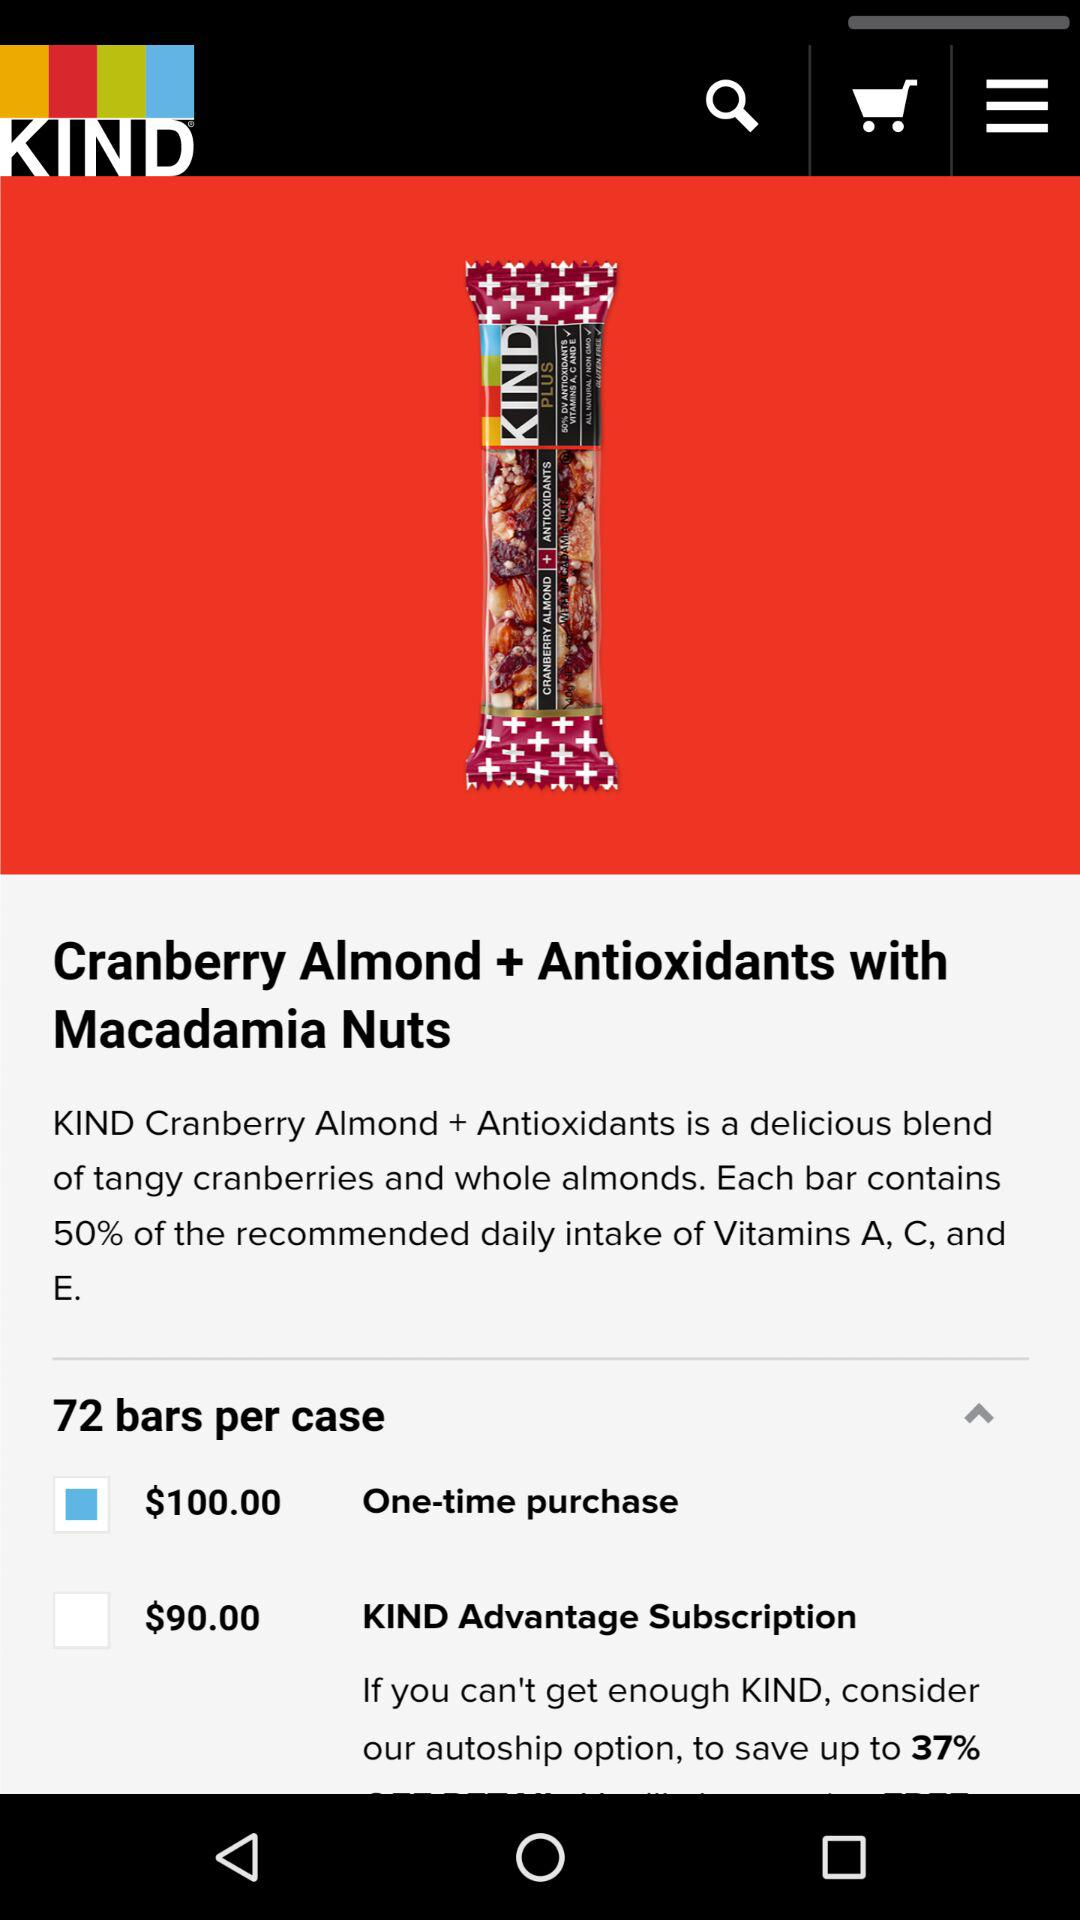How many calories are there in "Cranberry Almond + Antioxidants with Macadamia Nuts"?
When the provided information is insufficient, respond with <no answer>. <no answer> 